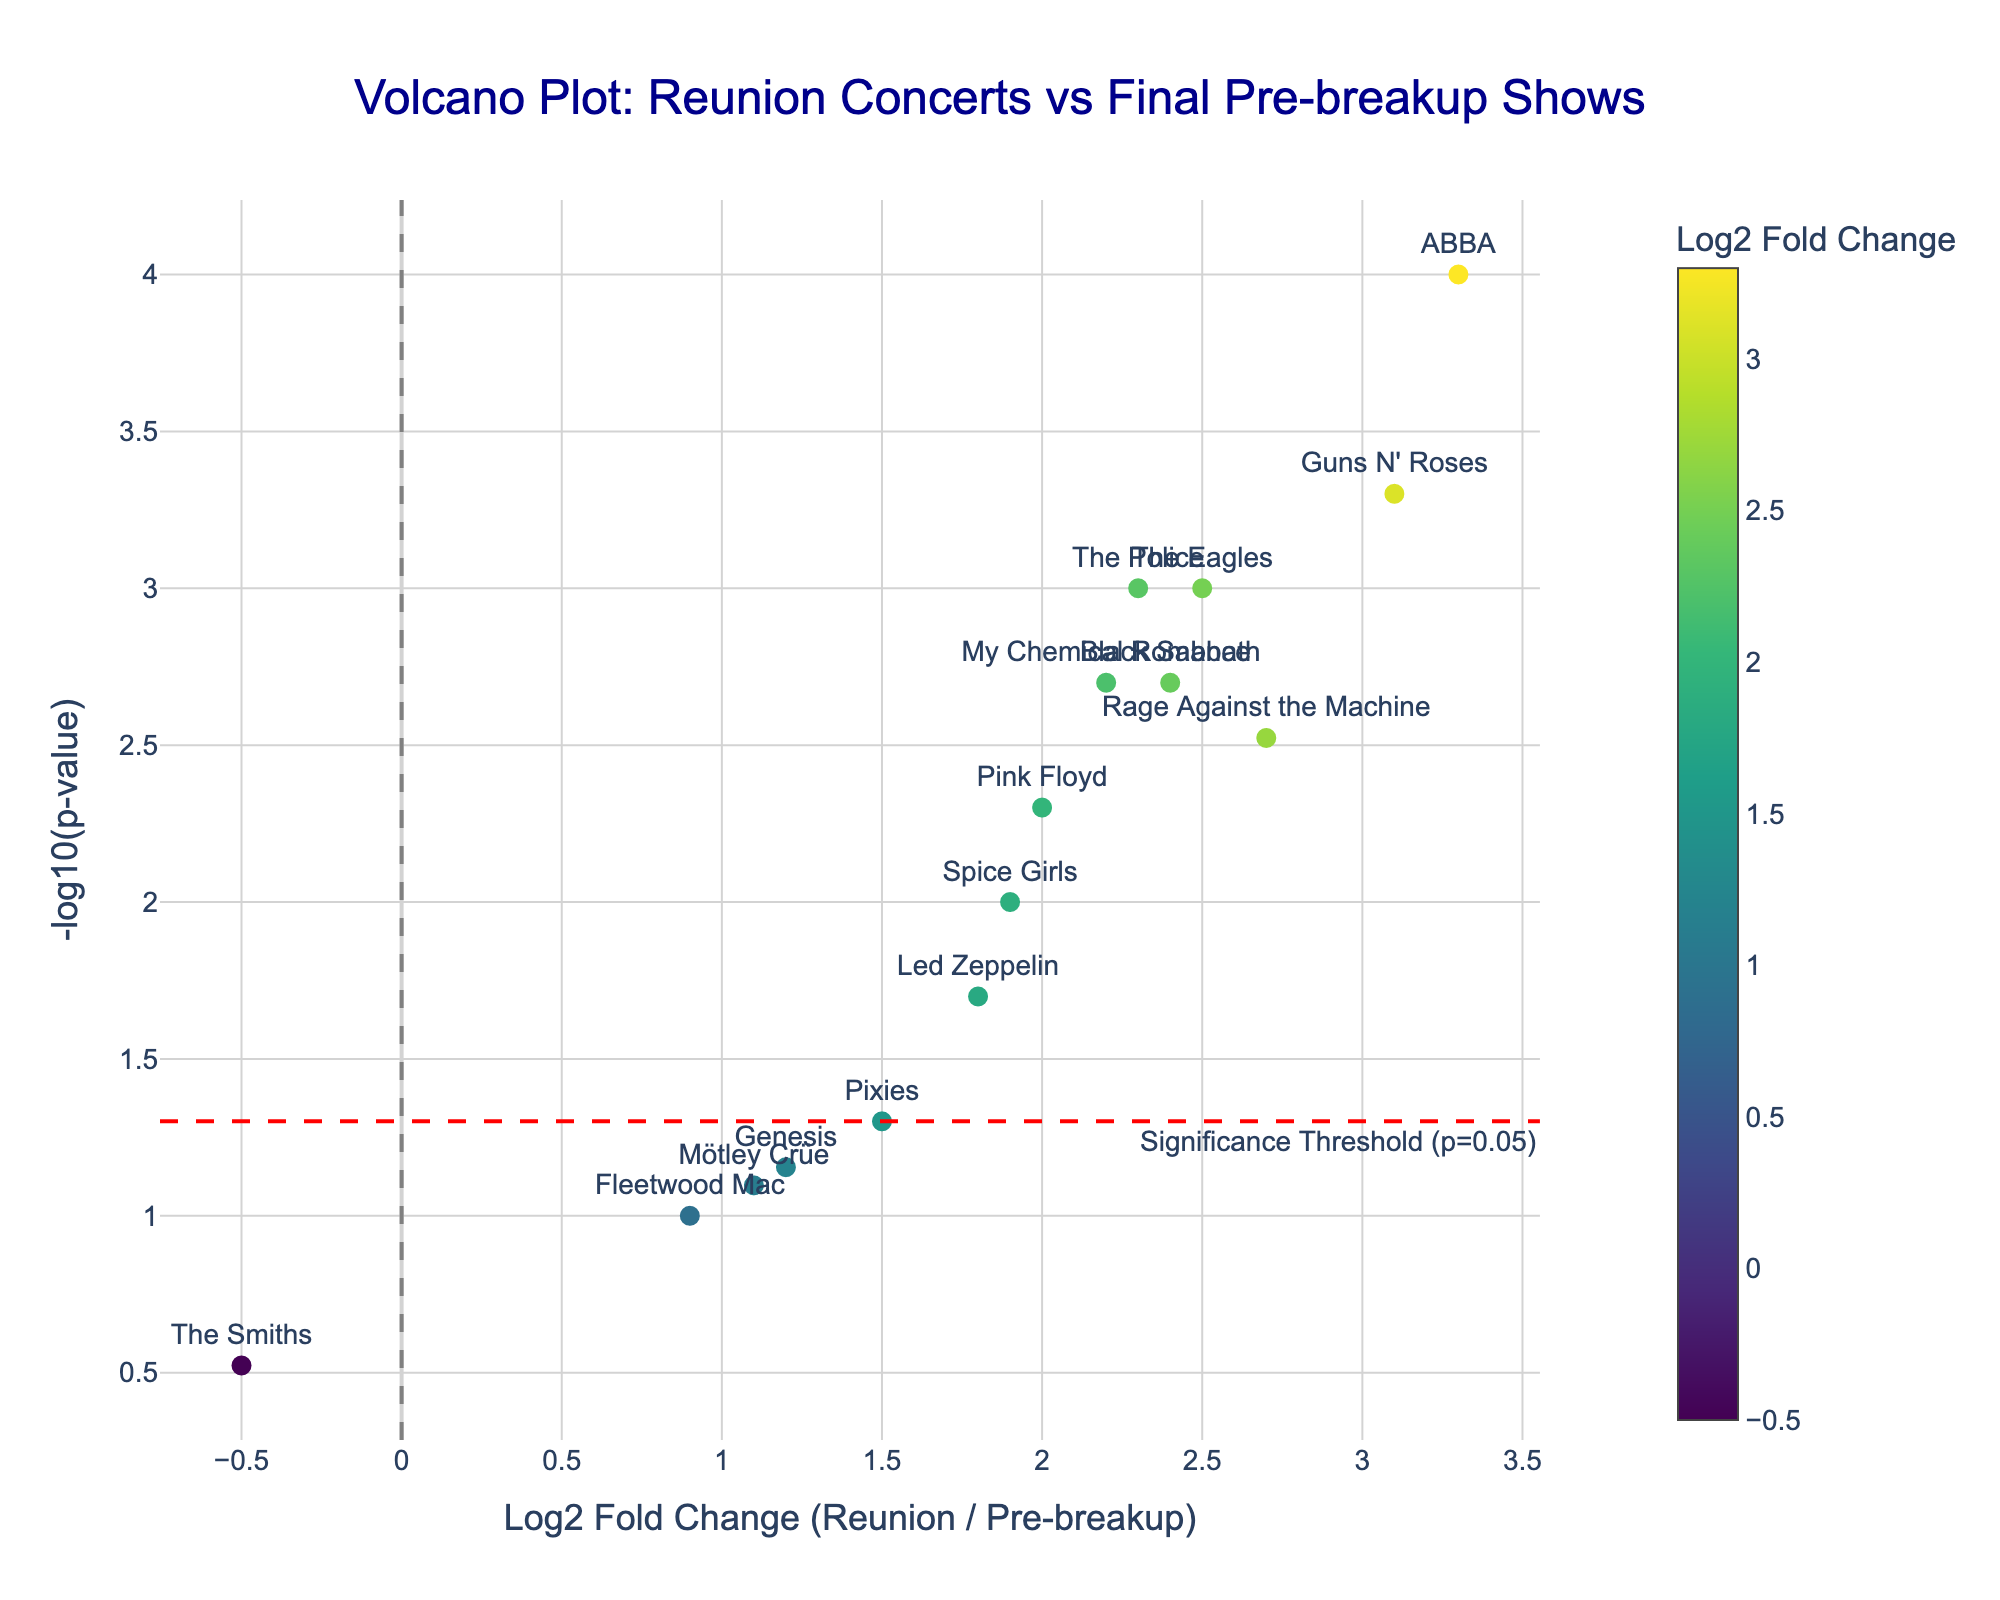How many bands are represented in the plot? The number of bands can be counted by looking at the data points labeled with band names in the plot. There are 15 bands in total.
Answer: 15 What is the title of the plot? The title of the plot is usually displayed at the top center of the figure.
Answer: Volcano Plot: Reunion Concerts vs Final Pre-breakup Shows Which band has the highest Log2 Fold Change? The highest Log2 Fold Change is indicated by the data point farthest to the right on the x-axis. The band ABBA is positioned at the highest value of Log2 Fold Change (3.3).
Answer: ABBA Which band has the most significant p-value? The most significant p-value is represented by the data point at the highest position on the y-axis (-log10(p-value)). ABBA has a p-value of 0.0001 and is positioned the highest.
Answer: ABBA How many bands have a Log2 Fold Change greater than 2? To find the number of bands with a Log2 Fold Change greater than 2, we count the data points located to the right of x=2. The bands are The Police, Guns N' Roses, Rage Against the Machine, My Chemical Romance, The Eagles, ABBA, and Black Sabbath. There are 7 such bands.
Answer: 7 Which band has a negative Log2 Fold Change and what does it indicate? The negative Log2 Fold Change is to the left of x=0 on the x-axis. The Smiths is the only band with a negative Log2 Fold Change (-0.5). This indicates that ticket sales and revenue for their reunion concert were lower than for their final pre-breakup show.
Answer: The Smiths What is the significance threshold used in the plot? The significance threshold is indicated by the horizontal red dashed line on the plot. This is at -log10(0.05), which equals 1.3.
Answer: 1.3 Which band is the closest to the significance threshold but still significant? Significant bands are those above the red dashed line. The closest significant band to the threshold line is Led Zeppelin with a p-value of 0.02, positioned just above the threshold.
Answer: Led Zeppelin Which two bands have nearly similar Log2 Fold Change values around 2.0? By analyzing the x-axis for Log2 Fold Change around 2.0, Pink Floyd (2.0) and My Chemical Romance (2.2) have nearly similar values.
Answer: Pink Floyd and My Chemical Romance What is observed about bands that have p-values greater than 0.05? Bands with p-values greater than 0.05 have data points below the red dashed line. Fleetwood Mac (0.1), Pixies (0.05), Mötley Crüe (0.08), The Smiths (0.3), and Genesis (0.07) all fall below the significance threshold, indicating that their ticket sales and revenue changes are not statistically significant.
Answer: Their changes are not statistically significant 